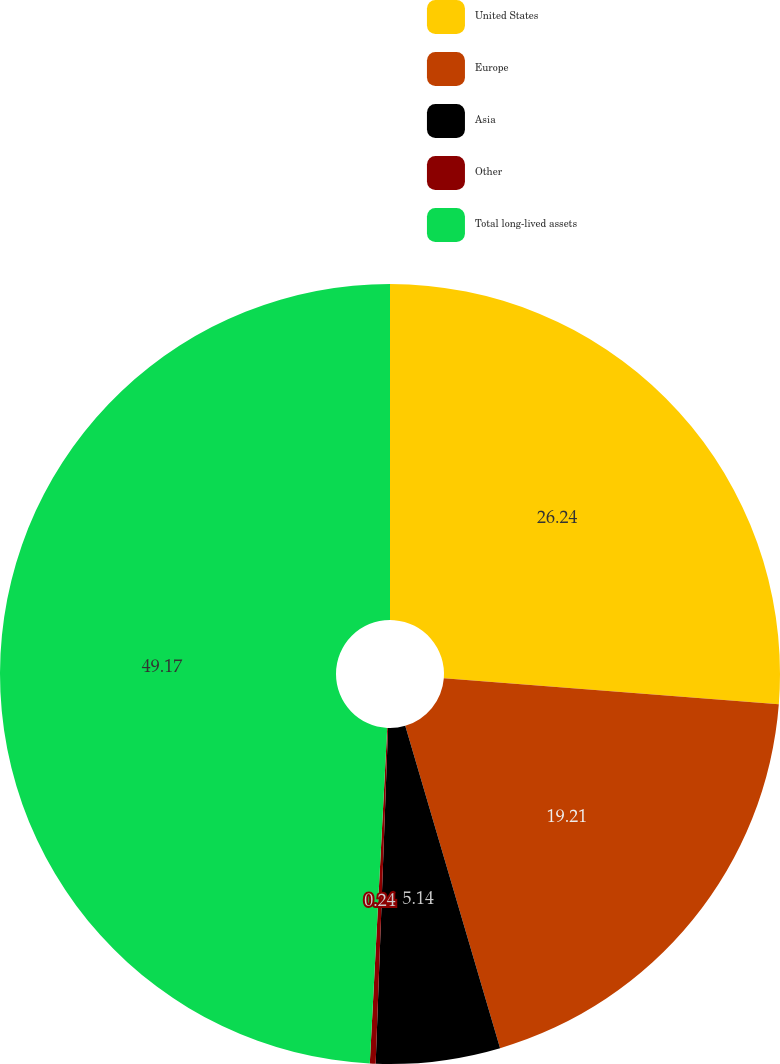Convert chart. <chart><loc_0><loc_0><loc_500><loc_500><pie_chart><fcel>United States<fcel>Europe<fcel>Asia<fcel>Other<fcel>Total long-lived assets<nl><fcel>26.24%<fcel>19.21%<fcel>5.14%<fcel>0.24%<fcel>49.18%<nl></chart> 